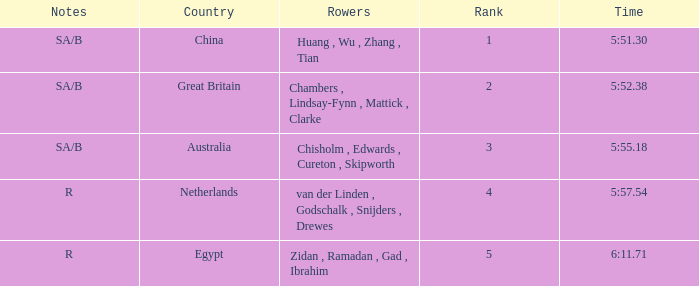What country is ranked larger than 4? Egypt. 